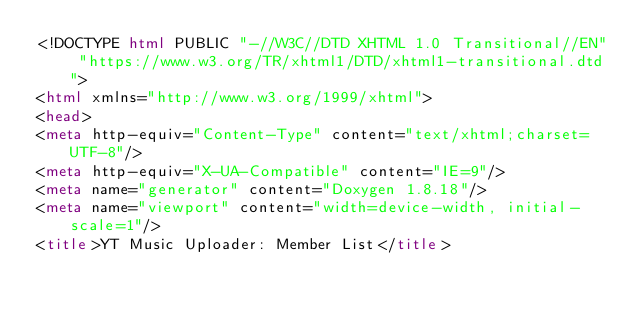Convert code to text. <code><loc_0><loc_0><loc_500><loc_500><_HTML_><!DOCTYPE html PUBLIC "-//W3C//DTD XHTML 1.0 Transitional//EN" "https://www.w3.org/TR/xhtml1/DTD/xhtml1-transitional.dtd">
<html xmlns="http://www.w3.org/1999/xhtml">
<head>
<meta http-equiv="Content-Type" content="text/xhtml;charset=UTF-8"/>
<meta http-equiv="X-UA-Compatible" content="IE=9"/>
<meta name="generator" content="Doxygen 1.8.18"/>
<meta name="viewport" content="width=device-width, initial-scale=1"/>
<title>YT Music Uploader: Member List</title></code> 